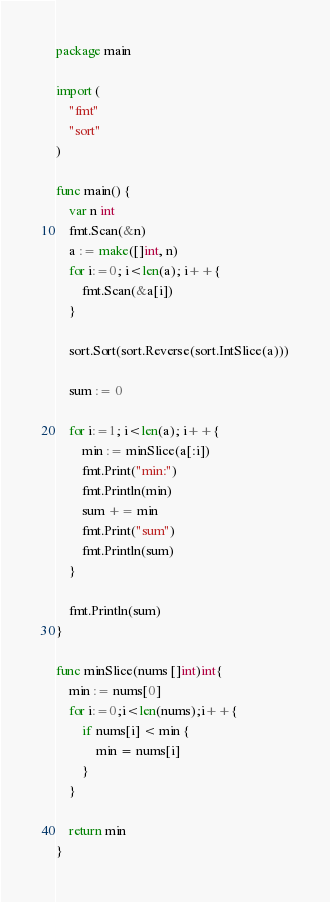Convert code to text. <code><loc_0><loc_0><loc_500><loc_500><_Go_>package main

import (
	"fmt"
	"sort"
)

func main() {
	var n int
	fmt.Scan(&n)
	a := make([]int, n)
	for i:=0; i<len(a); i++{
		fmt.Scan(&a[i])
	}

	sort.Sort(sort.Reverse(sort.IntSlice(a)))

	sum := 0

	for i:=1; i<len(a); i++{
		min := minSlice(a[:i])
		fmt.Print("min:")
		fmt.Println(min)
		sum += min
		fmt.Print("sum")
		fmt.Println(sum)
	}

	fmt.Println(sum)
}

func minSlice(nums []int)int{
	min := nums[0]
	for i:=0;i<len(nums);i++{
		if nums[i] < min {
			min = nums[i]
		}
	}

	return min
}</code> 